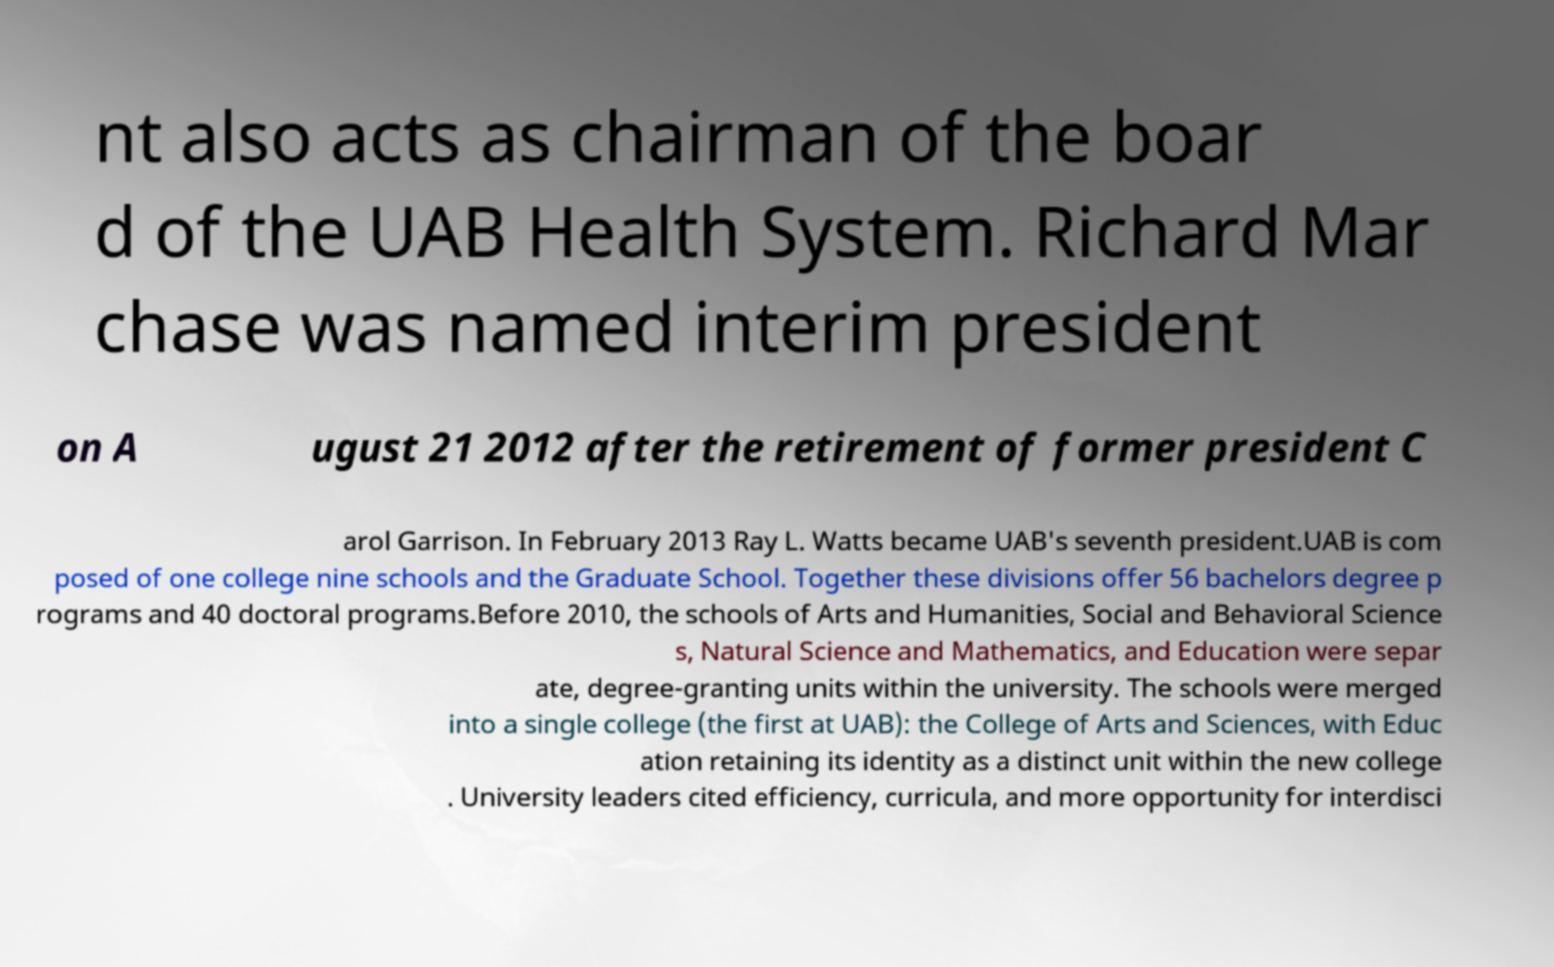Please identify and transcribe the text found in this image. nt also acts as chairman of the boar d of the UAB Health System. Richard Mar chase was named interim president on A ugust 21 2012 after the retirement of former president C arol Garrison. In February 2013 Ray L. Watts became UAB's seventh president.UAB is com posed of one college nine schools and the Graduate School. Together these divisions offer 56 bachelors degree p rograms and 40 doctoral programs.Before 2010, the schools of Arts and Humanities, Social and Behavioral Science s, Natural Science and Mathematics, and Education were separ ate, degree-granting units within the university. The schools were merged into a single college (the first at UAB): the College of Arts and Sciences, with Educ ation retaining its identity as a distinct unit within the new college . University leaders cited efficiency, curricula, and more opportunity for interdisci 